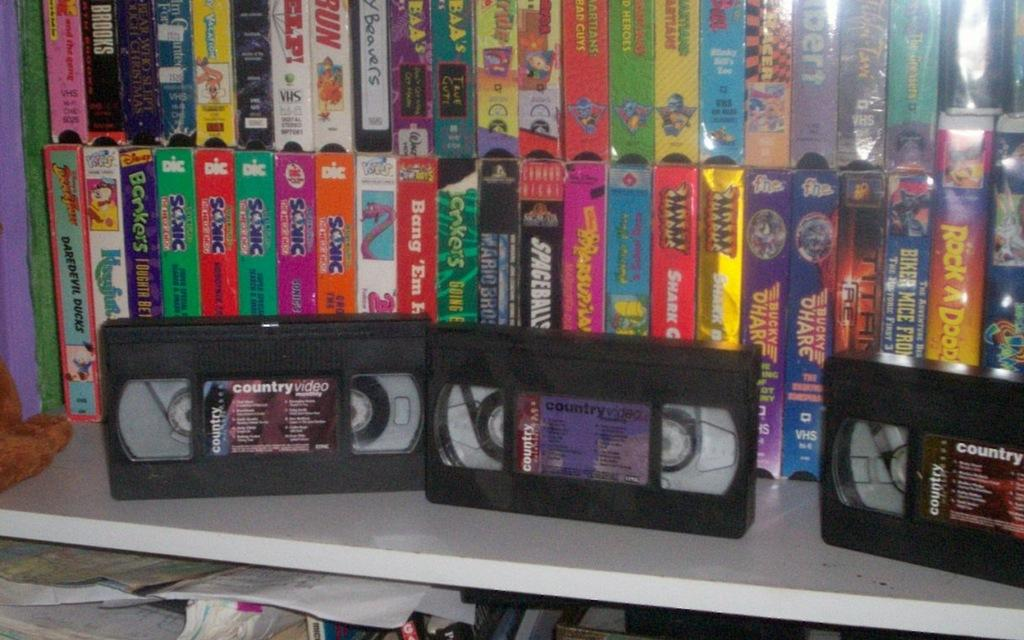<image>
Create a compact narrative representing the image presented. Three VHS tapes labeled Country Video sit in front of a bunch of VHS tapes in cases. 